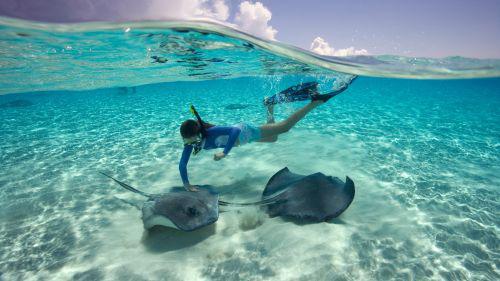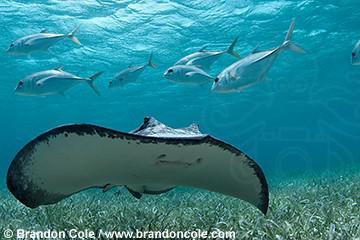The first image is the image on the left, the second image is the image on the right. Assess this claim about the two images: "The image on the right contains one human swimming underwater.". Correct or not? Answer yes or no. No. The first image is the image on the left, the second image is the image on the right. For the images displayed, is the sentence "There are less than five fish visible." factually correct? Answer yes or no. No. 